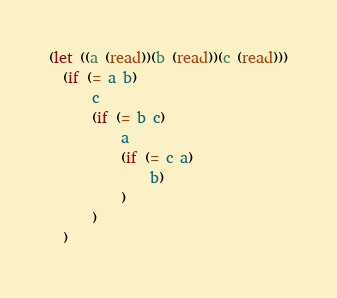Convert code to text. <code><loc_0><loc_0><loc_500><loc_500><_Scheme_>(let ((a (read))(b (read))(c (read)))
  (if (= a b)
      c
      (if (= b c)
          a
          (if (= c a)
              b)
          )
      )
  )
</code> 